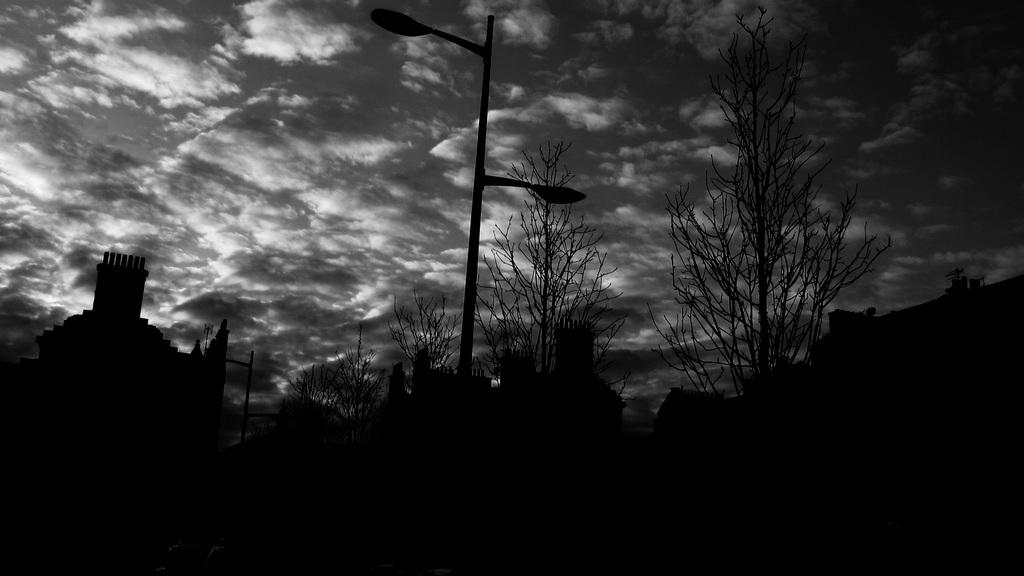What is the color scheme of the image? The image is black and white. What type of natural elements can be seen in the image? There are trees in the image. What type of man-made structures are present in the image? There are buildings in the image. What other objects can be seen in the image? There is a pole and a street light in the image. What is visible in the background of the image? The sky with clouds is visible in the background of the image. Can you see any signs of a wound on the trees in the image? There is no indication of a wound on the trees in the image; they appear to be healthy. Is there a trail visible in the image? There is no trail visible in the image; it primarily features trees, buildings, a pole, and a street light. 